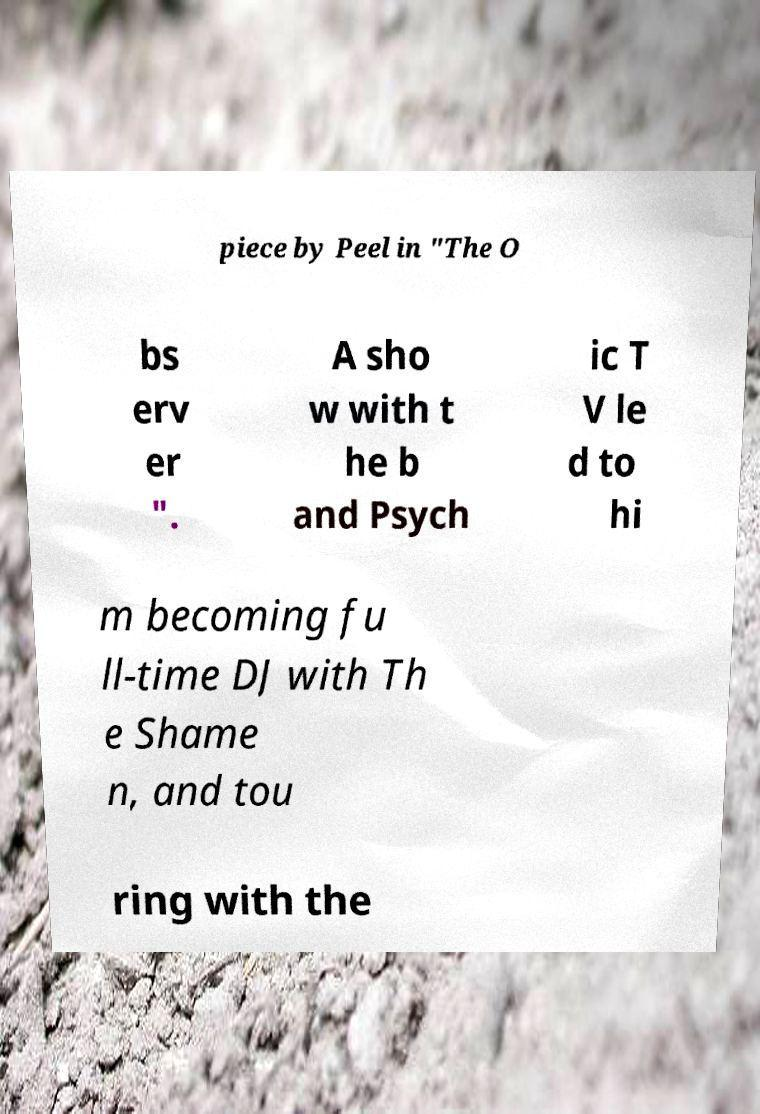Can you read and provide the text displayed in the image?This photo seems to have some interesting text. Can you extract and type it out for me? piece by Peel in "The O bs erv er ". A sho w with t he b and Psych ic T V le d to hi m becoming fu ll-time DJ with Th e Shame n, and tou ring with the 